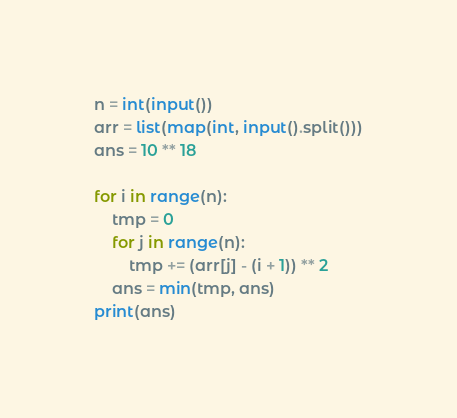<code> <loc_0><loc_0><loc_500><loc_500><_Python_>n = int(input())
arr = list(map(int, input().split()))
ans = 10 ** 18

for i in range(n):
    tmp = 0
    for j in range(n):
        tmp += (arr[j] - (i + 1)) ** 2
    ans = min(tmp, ans)
print(ans)
</code> 